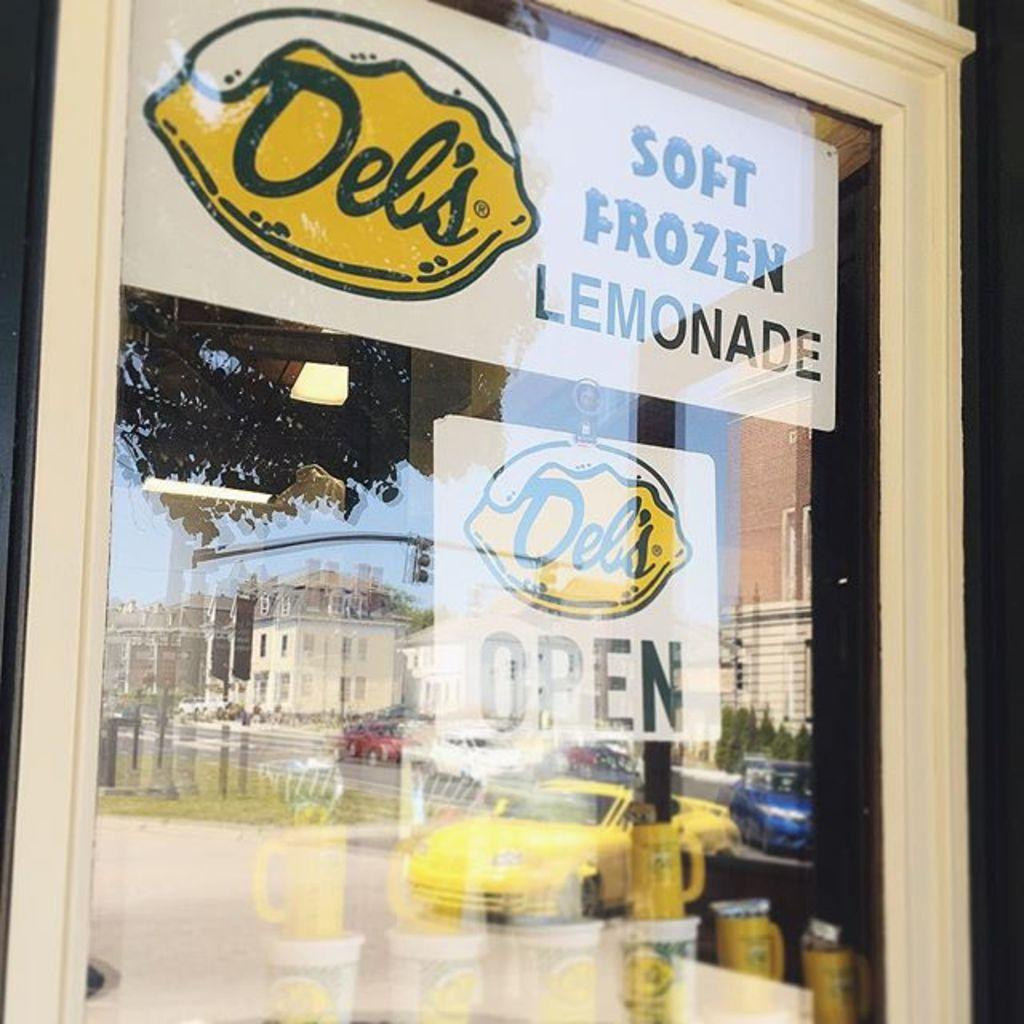<image>
Write a terse but informative summary of the picture. The store front of Del's Soft Frozen Lemonade shows the store is open. 